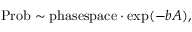<formula> <loc_0><loc_0><loc_500><loc_500>P r o b \sim p h a s e s p a c e \cdot \exp ( - b A ) ,</formula> 